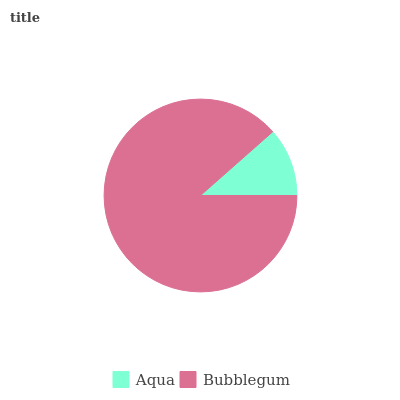Is Aqua the minimum?
Answer yes or no. Yes. Is Bubblegum the maximum?
Answer yes or no. Yes. Is Bubblegum the minimum?
Answer yes or no. No. Is Bubblegum greater than Aqua?
Answer yes or no. Yes. Is Aqua less than Bubblegum?
Answer yes or no. Yes. Is Aqua greater than Bubblegum?
Answer yes or no. No. Is Bubblegum less than Aqua?
Answer yes or no. No. Is Bubblegum the high median?
Answer yes or no. Yes. Is Aqua the low median?
Answer yes or no. Yes. Is Aqua the high median?
Answer yes or no. No. Is Bubblegum the low median?
Answer yes or no. No. 